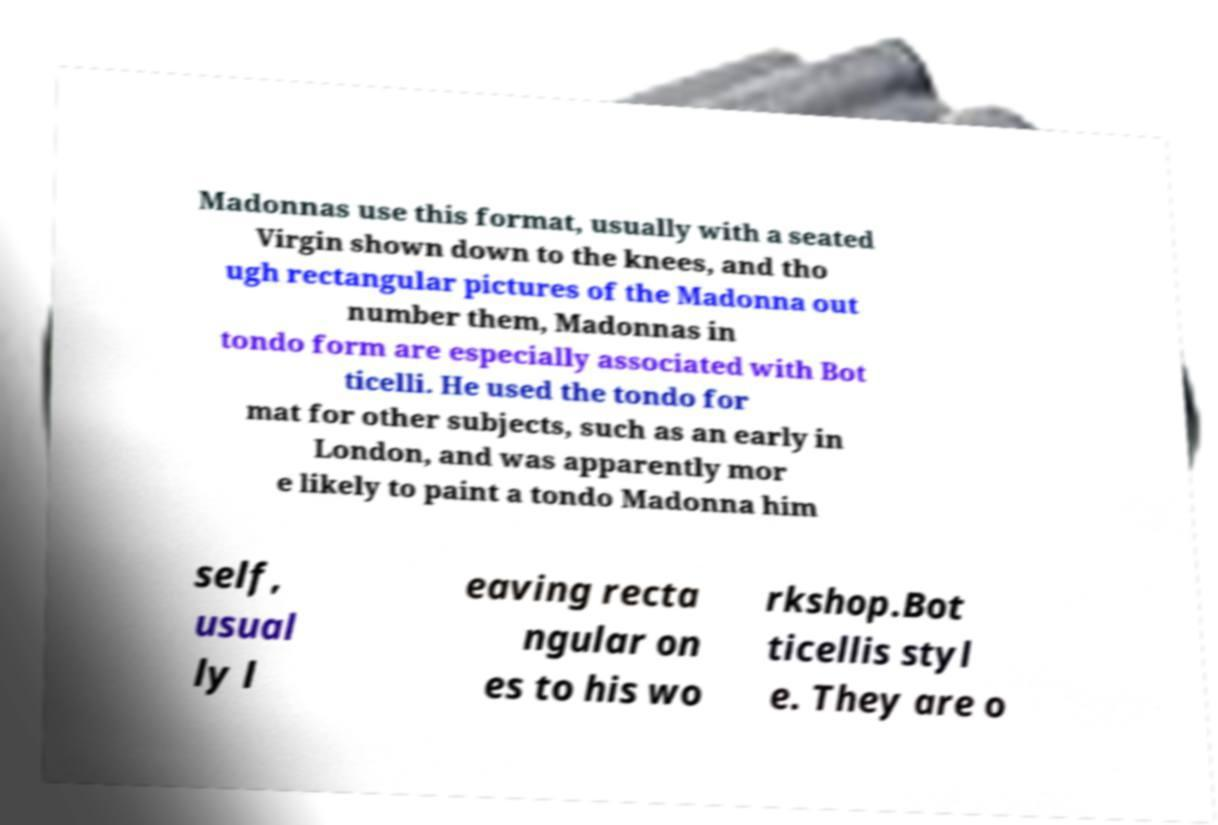For documentation purposes, I need the text within this image transcribed. Could you provide that? Madonnas use this format, usually with a seated Virgin shown down to the knees, and tho ugh rectangular pictures of the Madonna out number them, Madonnas in tondo form are especially associated with Bot ticelli. He used the tondo for mat for other subjects, such as an early in London, and was apparently mor e likely to paint a tondo Madonna him self, usual ly l eaving recta ngular on es to his wo rkshop.Bot ticellis styl e. They are o 